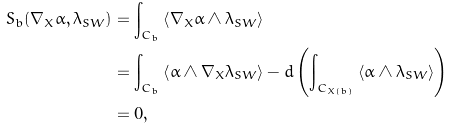<formula> <loc_0><loc_0><loc_500><loc_500>S _ { b } ( \nabla _ { X } \alpha , \lambda _ { S W } ) & = \int _ { C _ { b } } \left < \nabla _ { X } \alpha \wedge \lambda _ { S W } \right > \\ & = \int _ { C _ { b } } \left < \alpha \wedge \nabla _ { X } \lambda _ { S W } \right > - d \left ( \int _ { C _ { X ( b ) } } \left < \alpha \wedge \lambda _ { S W } \right > \right ) \\ & = 0 ,</formula> 